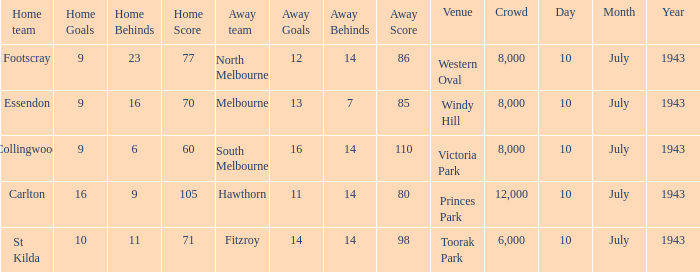When the Venue was victoria park, what was the Away team score? 16.14 (110). 